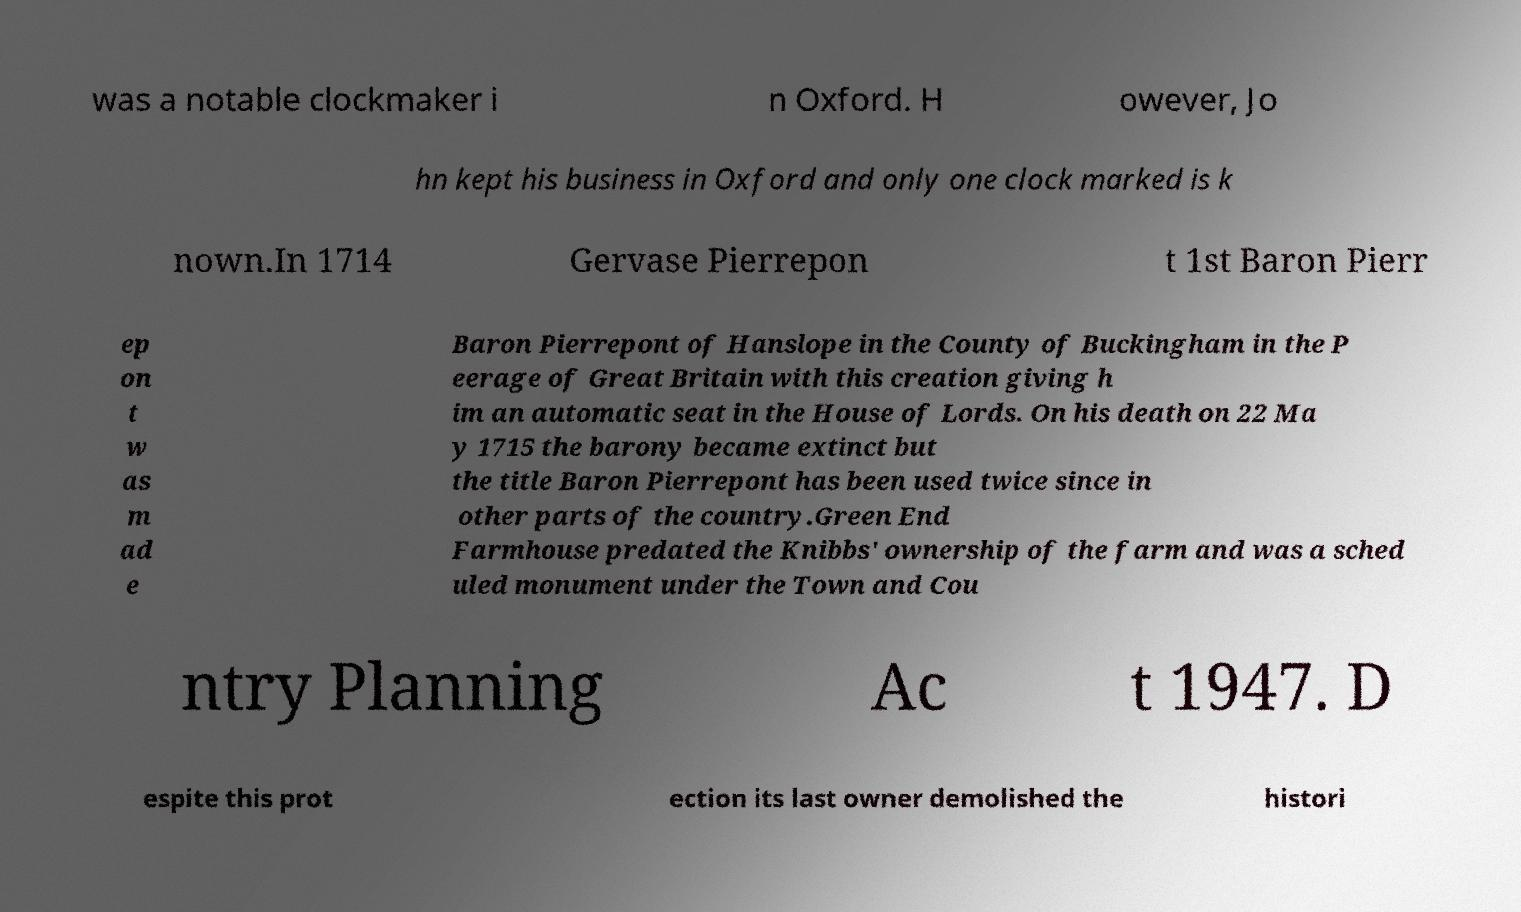Can you read and provide the text displayed in the image?This photo seems to have some interesting text. Can you extract and type it out for me? was a notable clockmaker i n Oxford. H owever, Jo hn kept his business in Oxford and only one clock marked is k nown.In 1714 Gervase Pierrepon t 1st Baron Pierr ep on t w as m ad e Baron Pierrepont of Hanslope in the County of Buckingham in the P eerage of Great Britain with this creation giving h im an automatic seat in the House of Lords. On his death on 22 Ma y 1715 the barony became extinct but the title Baron Pierrepont has been used twice since in other parts of the country.Green End Farmhouse predated the Knibbs' ownership of the farm and was a sched uled monument under the Town and Cou ntry Planning Ac t 1947. D espite this prot ection its last owner demolished the histori 